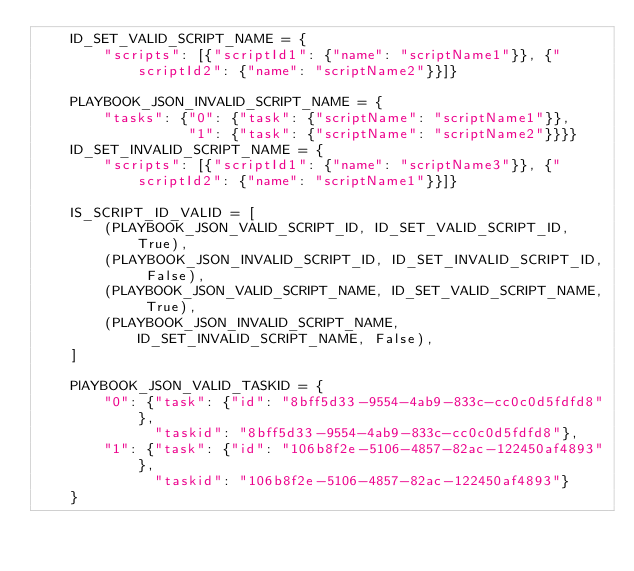Convert code to text. <code><loc_0><loc_0><loc_500><loc_500><_Python_>    ID_SET_VALID_SCRIPT_NAME = {
        "scripts": [{"scriptId1": {"name": "scriptName1"}}, {"scriptId2": {"name": "scriptName2"}}]}

    PLAYBOOK_JSON_INVALID_SCRIPT_NAME = {
        "tasks": {"0": {"task": {"scriptName": "scriptName1"}},
                  "1": {"task": {"scriptName": "scriptName2"}}}}
    ID_SET_INVALID_SCRIPT_NAME = {
        "scripts": [{"scriptId1": {"name": "scriptName3"}}, {"scriptId2": {"name": "scriptName1"}}]}

    IS_SCRIPT_ID_VALID = [
        (PLAYBOOK_JSON_VALID_SCRIPT_ID, ID_SET_VALID_SCRIPT_ID, True),
        (PLAYBOOK_JSON_INVALID_SCRIPT_ID, ID_SET_INVALID_SCRIPT_ID, False),
        (PLAYBOOK_JSON_VALID_SCRIPT_NAME, ID_SET_VALID_SCRIPT_NAME, True),
        (PLAYBOOK_JSON_INVALID_SCRIPT_NAME, ID_SET_INVALID_SCRIPT_NAME, False),
    ]

    PlAYBOOK_JSON_VALID_TASKID = {
        "0": {"task": {"id": "8bff5d33-9554-4ab9-833c-cc0c0d5fdfd8"},
              "taskid": "8bff5d33-9554-4ab9-833c-cc0c0d5fdfd8"},
        "1": {"task": {"id": "106b8f2e-5106-4857-82ac-122450af4893"},
              "taskid": "106b8f2e-5106-4857-82ac-122450af4893"}
    }
</code> 